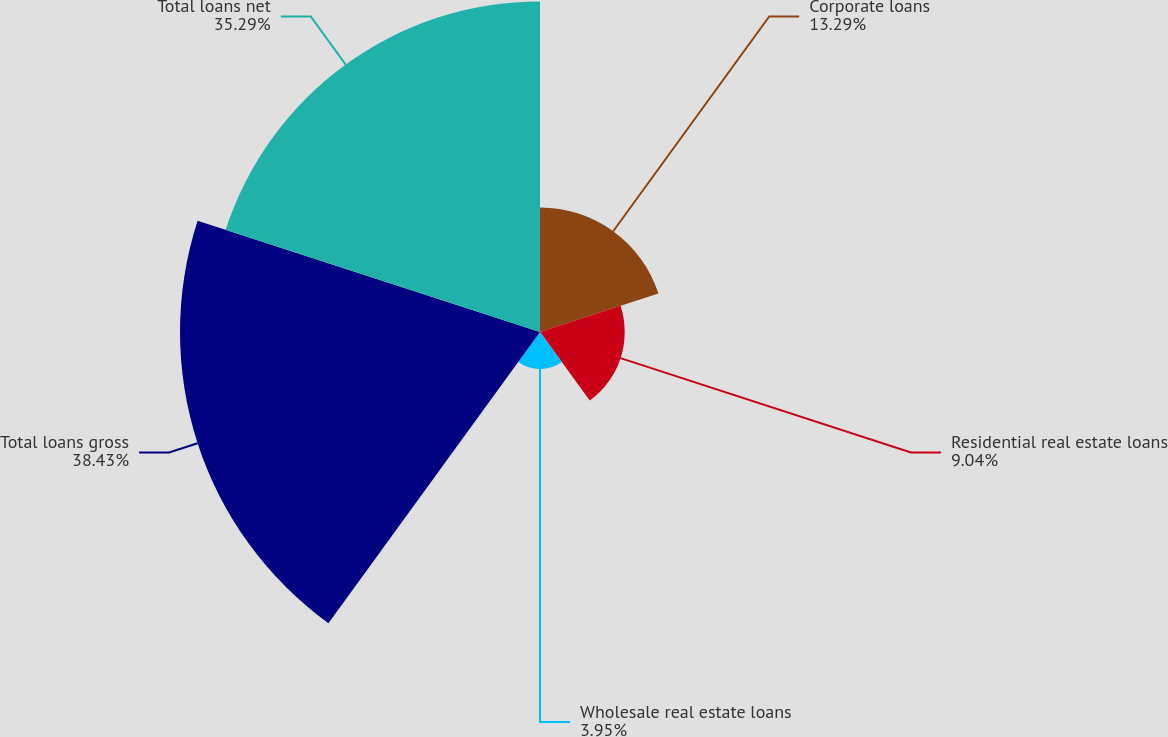<chart> <loc_0><loc_0><loc_500><loc_500><pie_chart><fcel>Corporate loans<fcel>Residential real estate loans<fcel>Wholesale real estate loans<fcel>Total loans gross<fcel>Total loans net<nl><fcel>13.29%<fcel>9.04%<fcel>3.95%<fcel>38.43%<fcel>35.29%<nl></chart> 